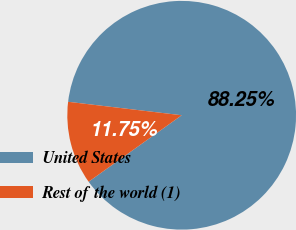Convert chart to OTSL. <chart><loc_0><loc_0><loc_500><loc_500><pie_chart><fcel>United States<fcel>Rest of the world (1)<nl><fcel>88.25%<fcel>11.75%<nl></chart> 